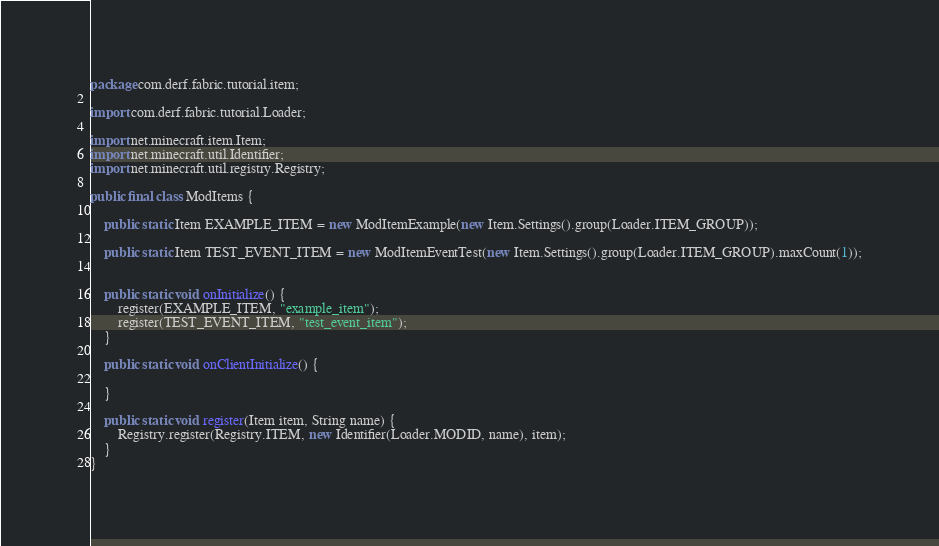Convert code to text. <code><loc_0><loc_0><loc_500><loc_500><_Java_>package com.derf.fabric.tutorial.item;

import com.derf.fabric.tutorial.Loader;

import net.minecraft.item.Item;
import net.minecraft.util.Identifier;
import net.minecraft.util.registry.Registry;

public final class ModItems {
	
	public static Item EXAMPLE_ITEM = new ModItemExample(new Item.Settings().group(Loader.ITEM_GROUP)); 
	
	public static Item TEST_EVENT_ITEM = new ModItemEventTest(new Item.Settings().group(Loader.ITEM_GROUP).maxCount(1));
	
	
	public static void onInitialize() {
		register(EXAMPLE_ITEM, "example_item");
		register(TEST_EVENT_ITEM, "test_event_item");
	}
	
	public static void onClientInitialize() {
		
	}
	
	public static void register(Item item, String name) {
		Registry.register(Registry.ITEM, new Identifier(Loader.MODID, name), item);
	}
}
</code> 